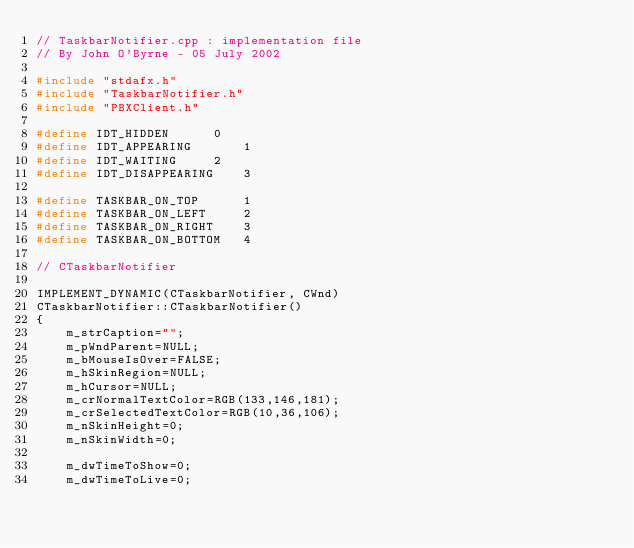<code> <loc_0><loc_0><loc_500><loc_500><_C++_>// TaskbarNotifier.cpp : implementation file
// By John O'Byrne - 05 July 2002

#include "stdafx.h"
#include "TaskbarNotifier.h"
#include "PBXClient.h"

#define IDT_HIDDEN		0
#define IDT_APPEARING		1
#define IDT_WAITING		2
#define IDT_DISAPPEARING	3

#define TASKBAR_ON_TOP		1
#define TASKBAR_ON_LEFT		2
#define TASKBAR_ON_RIGHT	3
#define TASKBAR_ON_BOTTOM	4

// CTaskbarNotifier

IMPLEMENT_DYNAMIC(CTaskbarNotifier, CWnd)
CTaskbarNotifier::CTaskbarNotifier()
{
	m_strCaption="";
	m_pWndParent=NULL;
	m_bMouseIsOver=FALSE;
	m_hSkinRegion=NULL;
	m_hCursor=NULL;
	m_crNormalTextColor=RGB(133,146,181);
	m_crSelectedTextColor=RGB(10,36,106);
	m_nSkinHeight=0;
	m_nSkinWidth=0;
	
	m_dwTimeToShow=0;
	m_dwTimeToLive=0;</code> 